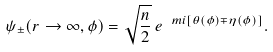Convert formula to latex. <formula><loc_0><loc_0><loc_500><loc_500>\psi _ { \pm } ( r \rightarrow \infty , \phi ) = \sqrt { \frac { n } { 2 } } \, e ^ { \ m i [ \theta ( \phi ) \mp \eta ( \phi ) ] } .</formula> 